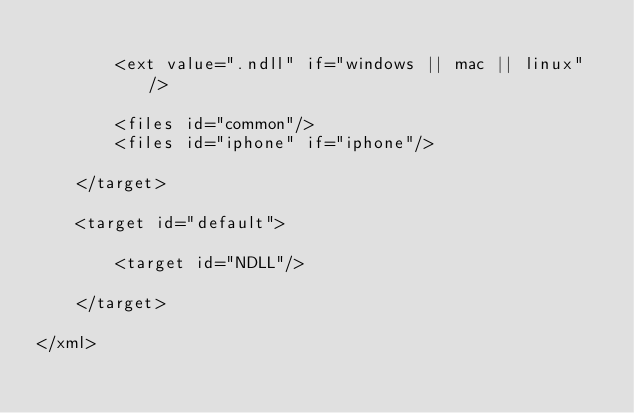Convert code to text. <code><loc_0><loc_0><loc_500><loc_500><_XML_>		
		<ext value=".ndll" if="windows || mac || linux" />
		
		<files id="common"/>
		<files id="iphone" if="iphone"/>
		
	</target>
	
	<target id="default">
		
		<target id="NDLL"/>
		
	</target>
	
</xml></code> 